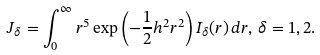<formula> <loc_0><loc_0><loc_500><loc_500>J _ { \delta } = \int _ { 0 } ^ { \infty } r ^ { 5 } \exp \left ( - \frac { 1 } { 2 } h ^ { 2 } r ^ { 2 } \right ) I _ { \delta } ( r ) \, d r , \, \delta = 1 , 2 .</formula> 